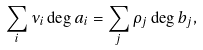<formula> <loc_0><loc_0><loc_500><loc_500>\sum _ { i } \nu _ { i } \deg a _ { i } = \sum _ { j } \rho _ { j } \deg b _ { j } ,</formula> 